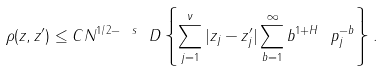Convert formula to latex. <formula><loc_0><loc_0><loc_500><loc_500>\rho ( z , z ^ { \prime } ) \leq C N ^ { 1 / 2 - \ s } \ D \left \{ \sum _ { j = 1 } ^ { \nu } | z _ { j } - z ^ { \prime } _ { j } | \sum _ { b = 1 } ^ { \infty } b ^ { 1 + H } \ p _ { j } ^ { - b } \right \} .</formula> 